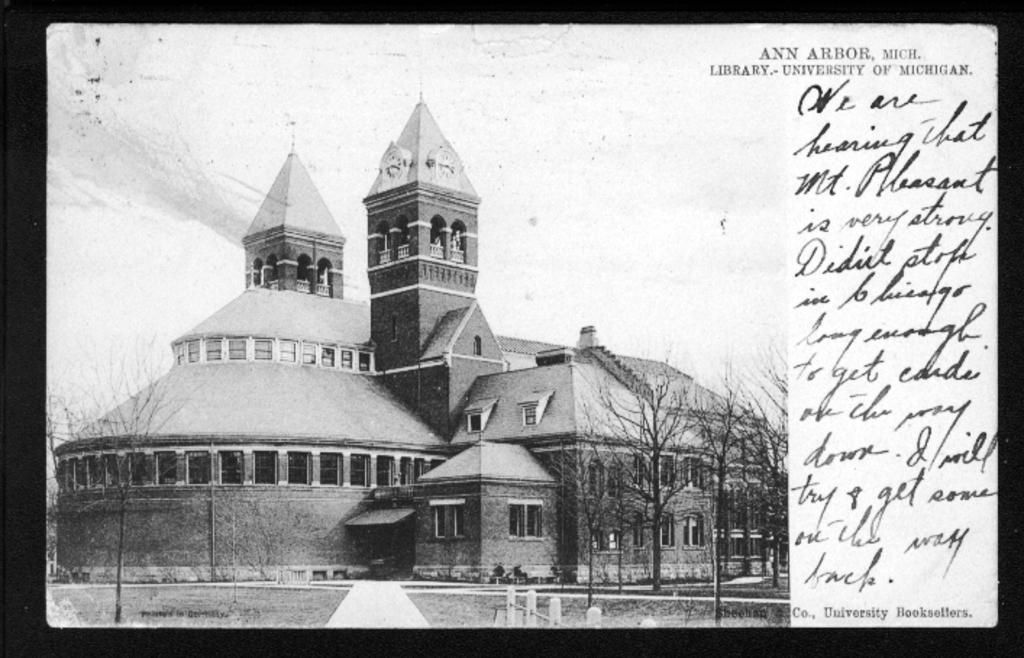What is the color scheme of the image? The image is black and white. What type of structure can be seen in the image? There is a fence in the image. What kind of path or way is visible in the image? There is a path or way in the image. What type of vegetation is present in the image? Dry trees are present in the image. What type of building is in the image? There is a house in the image. What is present on the right side of the image? There is written text and edited text on the right side of the image. What type of jelly is being used to decorate the house in the image? There is no jelly present in the image, and it is not being used to decorate the house. 